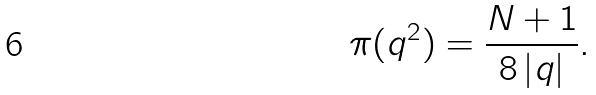<formula> <loc_0><loc_0><loc_500><loc_500>\pi ( q ^ { 2 } ) = \frac { N + 1 } { 8 \left | q \right | } .</formula> 